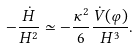Convert formula to latex. <formula><loc_0><loc_0><loc_500><loc_500>- \frac { \dot { H } } { H ^ { 2 } } \simeq - \frac { \kappa ^ { 2 } } { 6 } \frac { \dot { V } ( \varphi ) } { H ^ { 3 } } .</formula> 